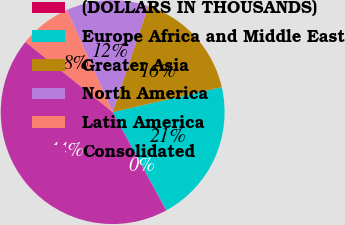<chart> <loc_0><loc_0><loc_500><loc_500><pie_chart><fcel>(DOLLARS IN THOUSANDS)<fcel>Europe Africa and Middle East<fcel>Greater Asia<fcel>North America<fcel>Latin America<fcel>Consolidated<nl><fcel>0.03%<fcel>20.62%<fcel>16.25%<fcel>11.88%<fcel>7.51%<fcel>43.71%<nl></chart> 